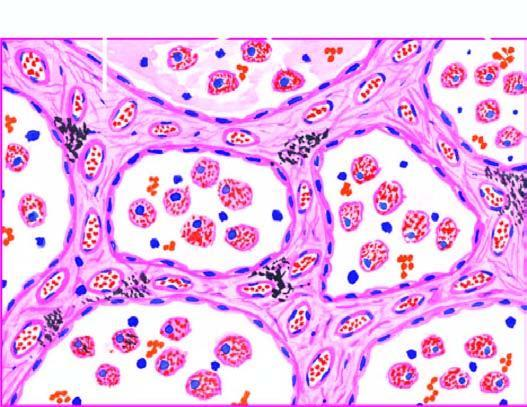re the interstitial vasculature widened and thickened due to congestion, oedema and mild fibrosis?
Answer the question using a single word or phrase. No 